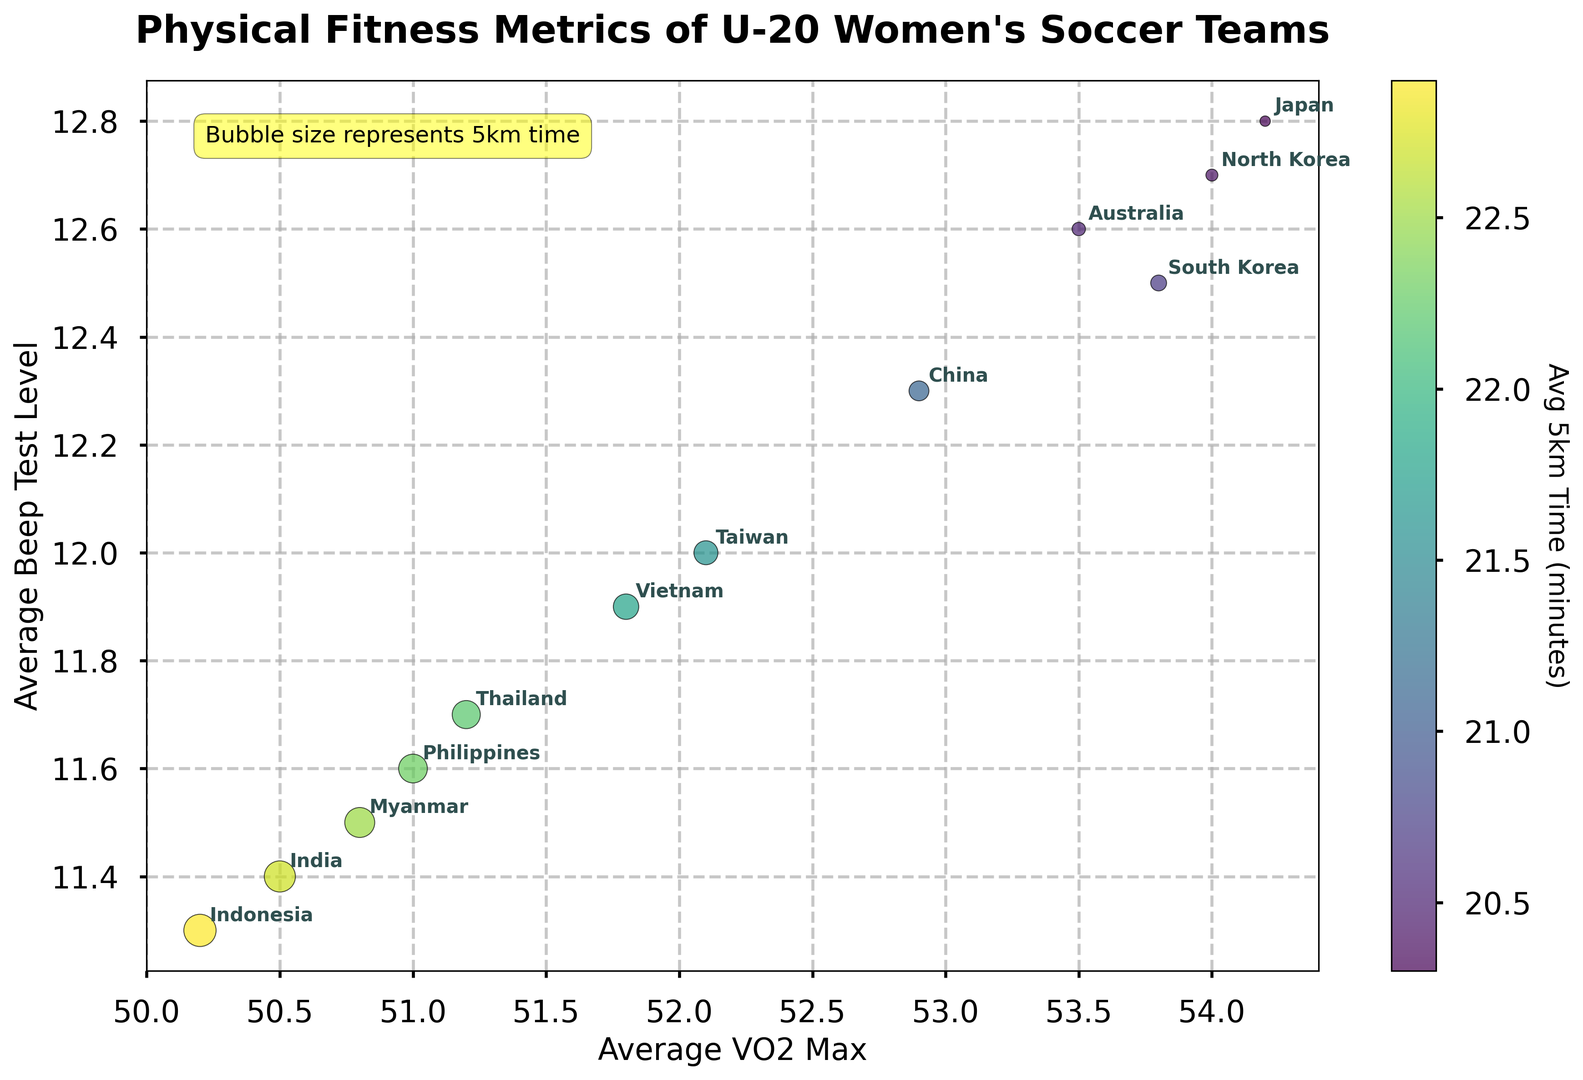Which team has the highest average VO2 Max? To find out which team has the highest average VO2 Max, look for the team with the highest x-coordinate in the scatter plot. The team with the highest value is Japan, with an average VO2 Max of 54.2.
Answer: Japan Which team has the shortest average 5km time? To determine the shortest average 5km time, look at the color bar and find the darkest bubble, which represents a shorter time. Japan has the shortest average 5km time of 20.3 minutes.
Answer: Japan Compare the average beep test levels of South Korea and North Korea. Which team performs better? Look at the y-coordinate values of South Korea and North Korea. South Korea has an average beep test level of 12.5, while North Korea's is 12.7. Since 12.7 is higher than 12.5, North Korea performs better.
Answer: North Korea What is the average 5km time for China, and how does it compare to Thailand's? Look at the color of the bubbles representing China and Thailand. China's average 5km time is 21.1 minutes, while Thailand's is 22.2 minutes. China has a faster average 5km time.
Answer: China has a faster time What's the difference in average VO2 Max between Japan and Indonesia? To find the difference, look at the x-coordinates for Japan and Indonesia. Japan's average VO2 Max is 54.2, and Indonesia's is 50.2. The difference is 54.2 - 50.2 = 4.0.
Answer: 4.0 Which team is represented by the largest bubble and what does this imply about their 5km time? Identify the largest bubble on the plot. The largest bubble belongs to Indonesia, implying that Indonesia has the longest average 5km time of 22.9 minutes.
Answer: Indonesia, longest 5km time Compare the average beep test levels of Vietnam and Taiwan. What do the values suggest about their endurance levels? Check the y-coordinates for Vietnam and Taiwan. Vietnam's average beep test level is 11.9 and Taiwan's is 12.0. Taiwan performs slightly better in terms of beep test levels, suggesting better endurance.
Answer: Taiwan, better endurance Identify the team with the lowest average VO2 Max and describe its position on the chart. Find the team with the lowest x-coordinate, which is Indonesia with an average VO2 Max of 50.2. It is located towards the left side of the chart.
Answer: Indonesia, left side Which teams have an average beep test level above 12.0 and how does their average 5km time compare? Look at the y-coordinates above 12.0: Japan, South Korea, China, Australia, and North Korea. Their average 5km times are: Japan 20.3, South Korea 20.7, China 21.1, Australia 20.5, and North Korea 20.4. These teams generally have faster average 5km times.
Answer: Generally faster 5km times 